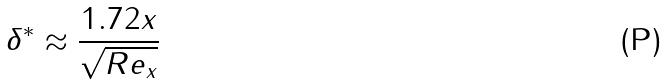Convert formula to latex. <formula><loc_0><loc_0><loc_500><loc_500>\delta ^ { * } \approx \frac { 1 . 7 2 x } { \sqrt { R e _ { x } } }</formula> 